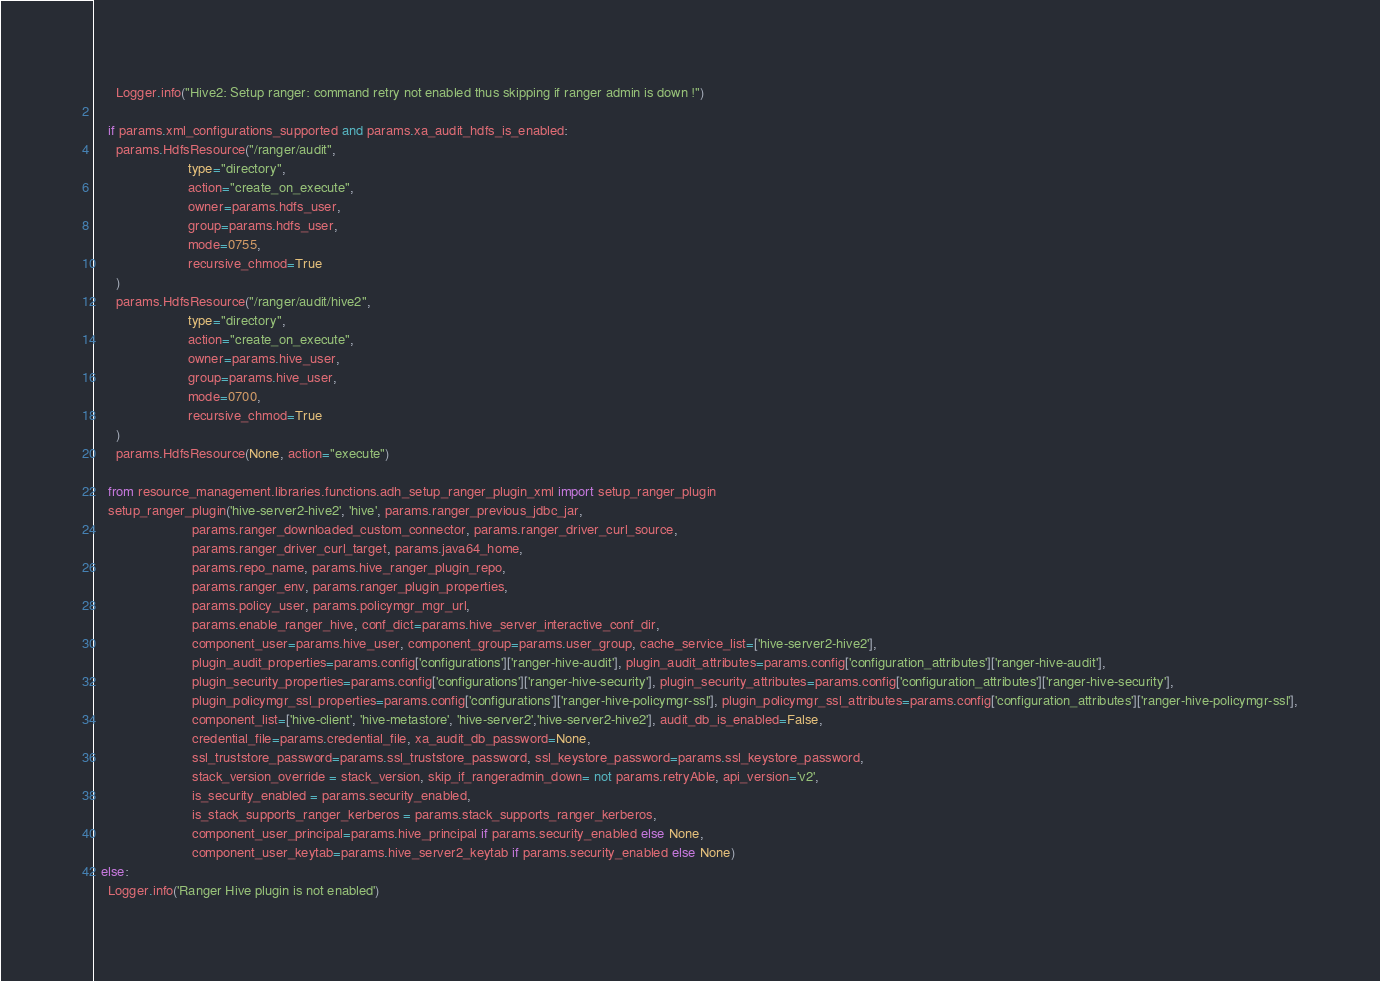<code> <loc_0><loc_0><loc_500><loc_500><_Python_>      Logger.info("Hive2: Setup ranger: command retry not enabled thus skipping if ranger admin is down !")

    if params.xml_configurations_supported and params.xa_audit_hdfs_is_enabled:
      params.HdfsResource("/ranger/audit",
                         type="directory",
                         action="create_on_execute",
                         owner=params.hdfs_user,
                         group=params.hdfs_user,
                         mode=0755,
                         recursive_chmod=True
      )
      params.HdfsResource("/ranger/audit/hive2",
                         type="directory",
                         action="create_on_execute",
                         owner=params.hive_user,
                         group=params.hive_user,
                         mode=0700,
                         recursive_chmod=True
      )
      params.HdfsResource(None, action="execute")

    from resource_management.libraries.functions.adh_setup_ranger_plugin_xml import setup_ranger_plugin
    setup_ranger_plugin('hive-server2-hive2', 'hive', params.ranger_previous_jdbc_jar,
                          params.ranger_downloaded_custom_connector, params.ranger_driver_curl_source,
                          params.ranger_driver_curl_target, params.java64_home,
                          params.repo_name, params.hive_ranger_plugin_repo,
                          params.ranger_env, params.ranger_plugin_properties,
                          params.policy_user, params.policymgr_mgr_url,
                          params.enable_ranger_hive, conf_dict=params.hive_server_interactive_conf_dir,
                          component_user=params.hive_user, component_group=params.user_group, cache_service_list=['hive-server2-hive2'],
                          plugin_audit_properties=params.config['configurations']['ranger-hive-audit'], plugin_audit_attributes=params.config['configuration_attributes']['ranger-hive-audit'],
                          plugin_security_properties=params.config['configurations']['ranger-hive-security'], plugin_security_attributes=params.config['configuration_attributes']['ranger-hive-security'],
                          plugin_policymgr_ssl_properties=params.config['configurations']['ranger-hive-policymgr-ssl'], plugin_policymgr_ssl_attributes=params.config['configuration_attributes']['ranger-hive-policymgr-ssl'],
                          component_list=['hive-client', 'hive-metastore', 'hive-server2','hive-server2-hive2'], audit_db_is_enabled=False,
                          credential_file=params.credential_file, xa_audit_db_password=None,
                          ssl_truststore_password=params.ssl_truststore_password, ssl_keystore_password=params.ssl_keystore_password,
                          stack_version_override = stack_version, skip_if_rangeradmin_down= not params.retryAble, api_version='v2',
                          is_security_enabled = params.security_enabled,
                          is_stack_supports_ranger_kerberos = params.stack_supports_ranger_kerberos,
                          component_user_principal=params.hive_principal if params.security_enabled else None,
                          component_user_keytab=params.hive_server2_keytab if params.security_enabled else None)
  else:
    Logger.info('Ranger Hive plugin is not enabled')

</code> 